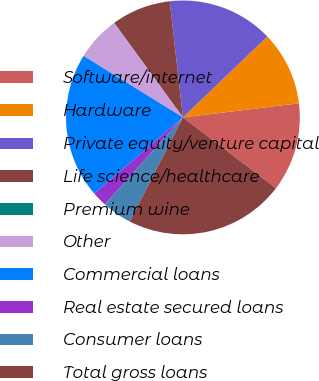Convert chart. <chart><loc_0><loc_0><loc_500><loc_500><pie_chart><fcel>Software/internet<fcel>Hardware<fcel>Private equity/venture capital<fcel>Life science/healthcare<fcel>Premium wine<fcel>Other<fcel>Commercial loans<fcel>Real estate secured loans<fcel>Consumer loans<fcel>Total gross loans<nl><fcel>12.28%<fcel>10.24%<fcel>14.64%<fcel>8.2%<fcel>0.03%<fcel>6.15%<fcel>20.12%<fcel>2.07%<fcel>4.11%<fcel>22.17%<nl></chart> 